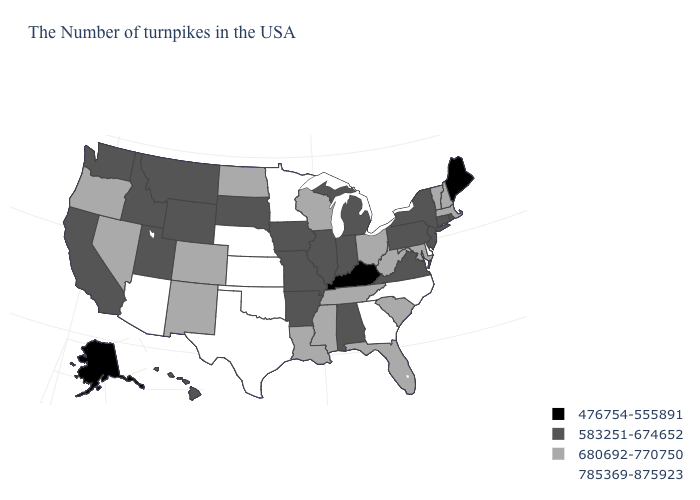What is the value of Massachusetts?
Quick response, please. 680692-770750. Does Maryland have a higher value than New Jersey?
Write a very short answer. Yes. Among the states that border Pennsylvania , which have the lowest value?
Concise answer only. New York, New Jersey. What is the highest value in the South ?
Keep it brief. 785369-875923. Name the states that have a value in the range 583251-674652?
Give a very brief answer. Rhode Island, Connecticut, New York, New Jersey, Pennsylvania, Virginia, Michigan, Indiana, Alabama, Illinois, Missouri, Arkansas, Iowa, South Dakota, Wyoming, Utah, Montana, Idaho, California, Washington, Hawaii. Which states have the highest value in the USA?
Concise answer only. Delaware, North Carolina, Georgia, Minnesota, Kansas, Nebraska, Oklahoma, Texas, Arizona. Which states have the lowest value in the MidWest?
Be succinct. Michigan, Indiana, Illinois, Missouri, Iowa, South Dakota. Name the states that have a value in the range 680692-770750?
Concise answer only. Massachusetts, New Hampshire, Vermont, Maryland, South Carolina, West Virginia, Ohio, Florida, Tennessee, Wisconsin, Mississippi, Louisiana, North Dakota, Colorado, New Mexico, Nevada, Oregon. Name the states that have a value in the range 476754-555891?
Short answer required. Maine, Kentucky, Alaska. Does Montana have a lower value than North Dakota?
Quick response, please. Yes. What is the value of Louisiana?
Quick response, please. 680692-770750. How many symbols are there in the legend?
Concise answer only. 4. Does the map have missing data?
Short answer required. No. How many symbols are there in the legend?
Quick response, please. 4. Name the states that have a value in the range 476754-555891?
Keep it brief. Maine, Kentucky, Alaska. 